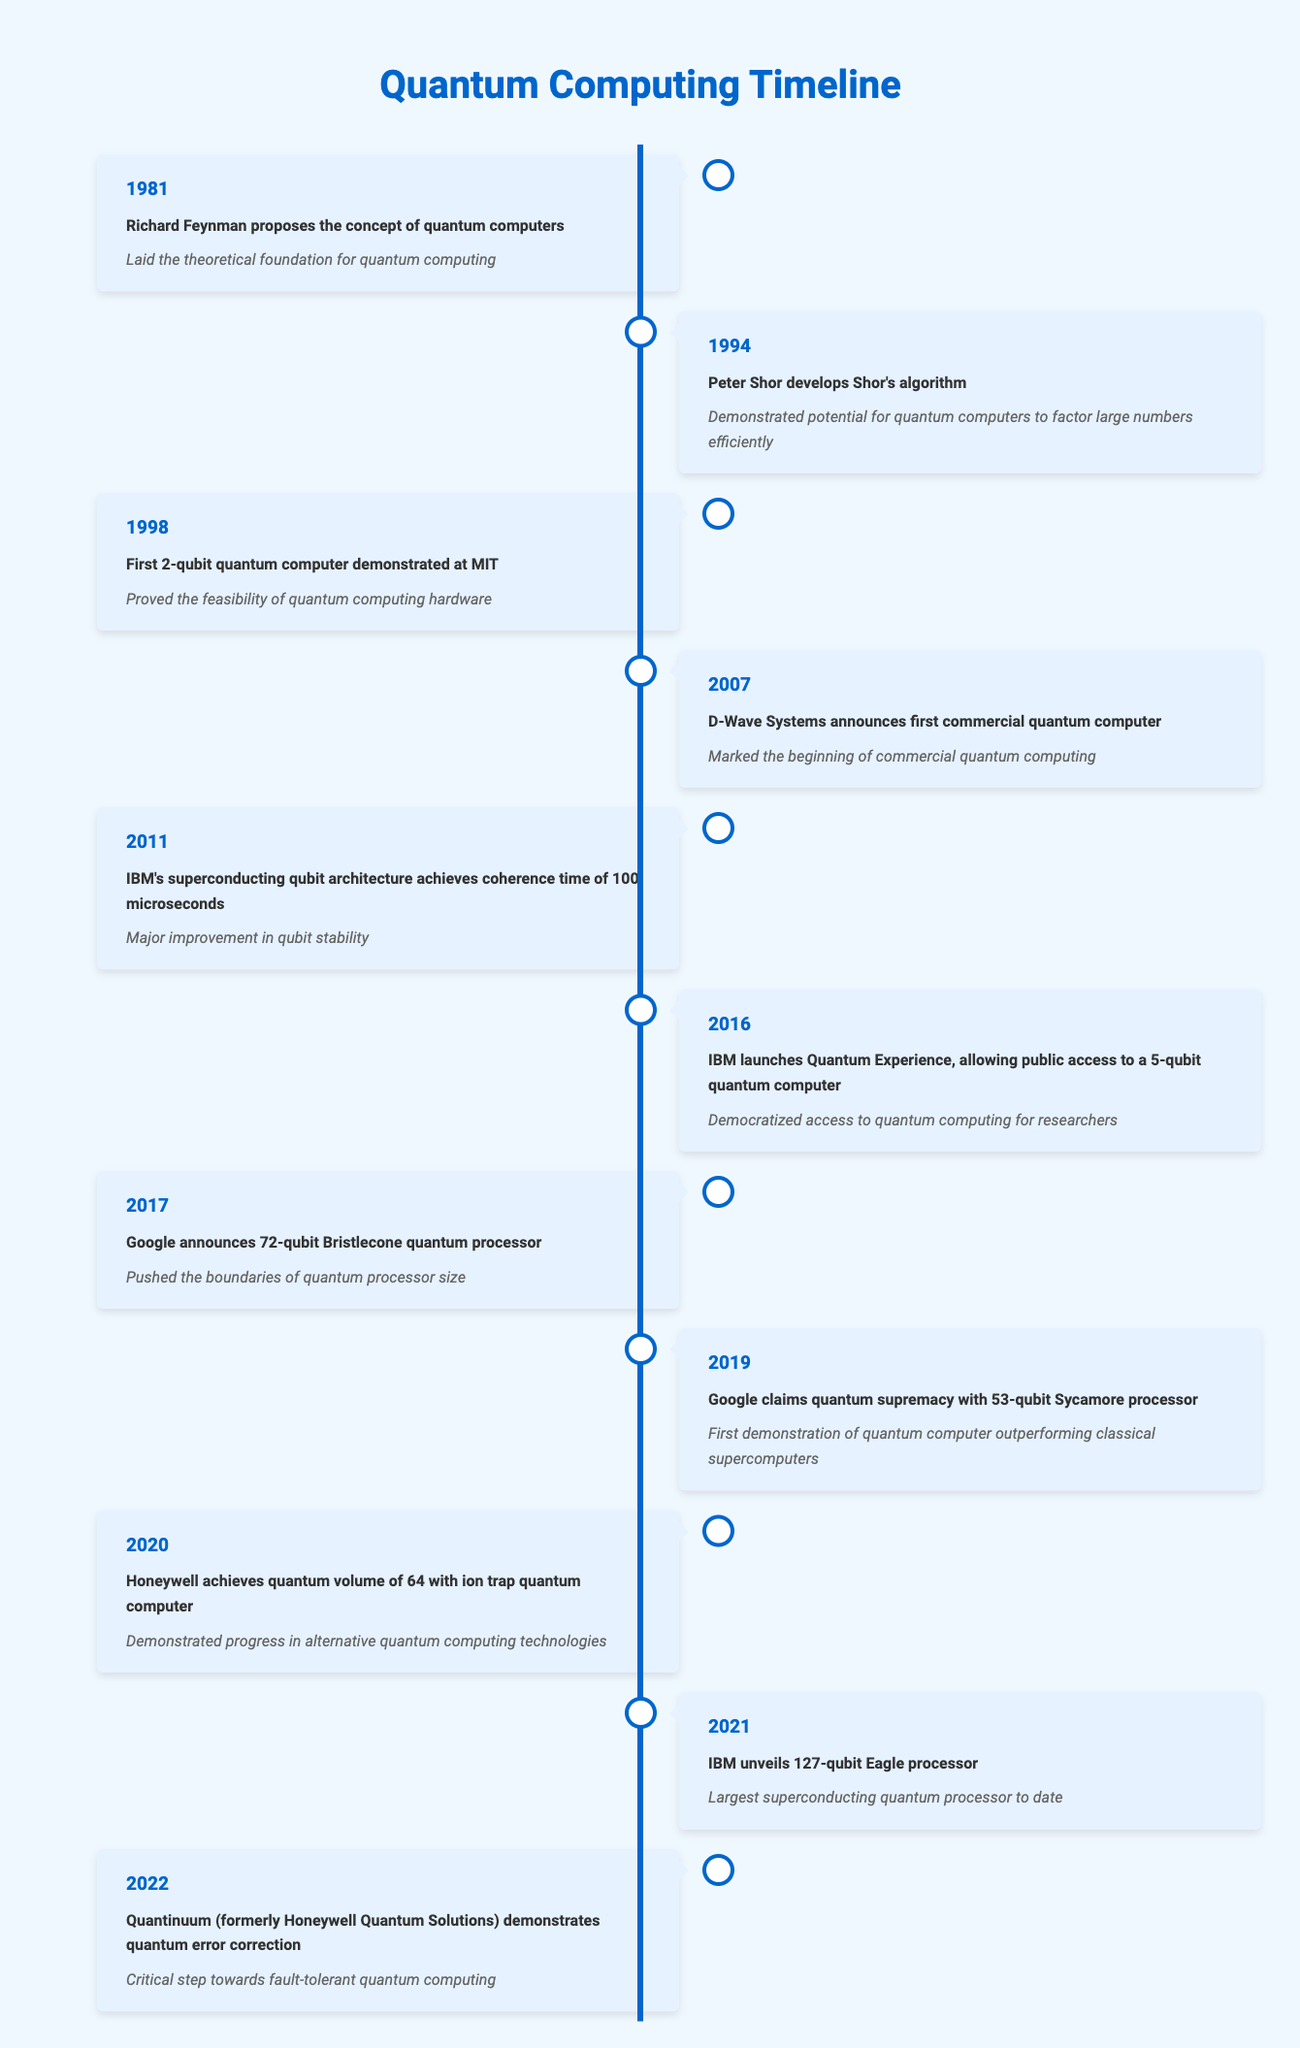What year did Richard Feynman propose the concept of quantum computers? The table shows that Richard Feynman proposed the concept of quantum computers in 1981.
Answer: 1981 What event occurred in 2019 related to quantum computing? In 2019, Google claimed quantum supremacy with the 53-qubit Sycamore processor, as indicated in the table.
Answer: Google claims quantum supremacy with 53-qubit Sycamore processor How many years span from the proposal of the concept of quantum computers to achieving quantum supremacy? The proposal was made in 1981 and quantum supremacy was claimed in 2019. The difference is 2019 - 1981 = 38 years.
Answer: 38 years Did IBM unveil a superconducting quantum processor larger than 72 qubits? Yes, according to the table, IBM unveiled a 127-qubit Eagle processor in 2021, which is larger than 72 qubits.
Answer: Yes What demonstrated a major improvement in qubit stability, and when did this happen? The table indicates that IBM's superconducting qubit architecture achieved a coherence time of 100 microseconds in 2011, demonstrating a major improvement in qubit stability.
Answer: IBM's superconducting qubit architecture in 2011 How many significant quantum computing events occurred between 1994 and 2022? The events listed in that time frame are: 1994, 1998, 2007, 2011, 2016, 2017, 2019, 2020, 2021, and 2022. Counting these gives a total of 10 significant events.
Answer: 10 significant events In what year did Honeywell achieve a quantum volume of 64? The table notes that Honeywell achieved a quantum volume of 64 with an ion trap quantum computer in 2020.
Answer: 2020 Which milestone is considered a critical step towards fault-tolerant quantum computing? According to the table, the demonstration of quantum error correction by Quantinuum in 2022 is considered a critical step towards fault-tolerant quantum computing.
Answer: Demonstration of quantum error correction by Quantinuum in 2022 What percentage of years listed in the table involved significant advancements in commercial quantum computing applications? The years related to commercial advancements are: 2007 (first commercial quantum computer), 2016 (Quantum Experience), and 2019 (quantum supremacy). There are 3 out of 42 years (1981-2022) represented, so (3/42)*100 = 7.14%.
Answer: 7.14% 